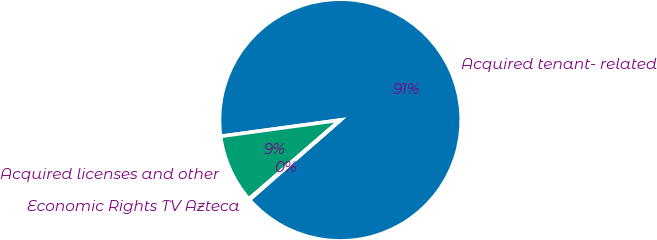<chart> <loc_0><loc_0><loc_500><loc_500><pie_chart><fcel>Acquired tenant- related<fcel>Acquired licenses and other<fcel>Economic Rights TV Azteca<nl><fcel>90.69%<fcel>9.18%<fcel>0.12%<nl></chart> 